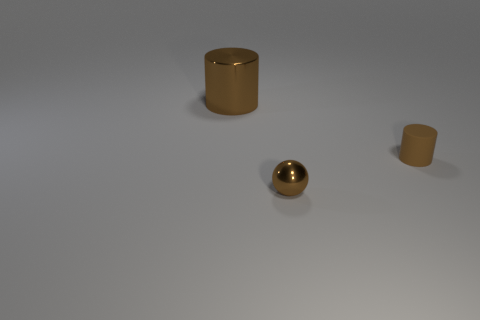What color is the other thing that is the same size as the brown rubber thing?
Make the answer very short. Brown. How many small objects are brown matte cylinders or red matte cylinders?
Your answer should be compact. 1. There is a brown object that is both on the right side of the large shiny thing and to the left of the small cylinder; what material is it made of?
Your answer should be very brief. Metal. Is the shape of the brown metal thing in front of the large shiny cylinder the same as the brown thing that is behind the small cylinder?
Your answer should be compact. No. What is the shape of the shiny thing that is the same color as the metal ball?
Your response must be concise. Cylinder. How many things are things right of the tiny metallic object or small brown balls?
Offer a very short reply. 2. Does the ball have the same size as the rubber object?
Keep it short and to the point. Yes. What is the size of the brown cylinder that is the same material as the brown ball?
Offer a very short reply. Large. Does the brown metal sphere have the same size as the brown thing to the right of the tiny shiny object?
Make the answer very short. Yes. There is a brown cylinder on the right side of the metal cylinder; what is it made of?
Your answer should be very brief. Rubber. 